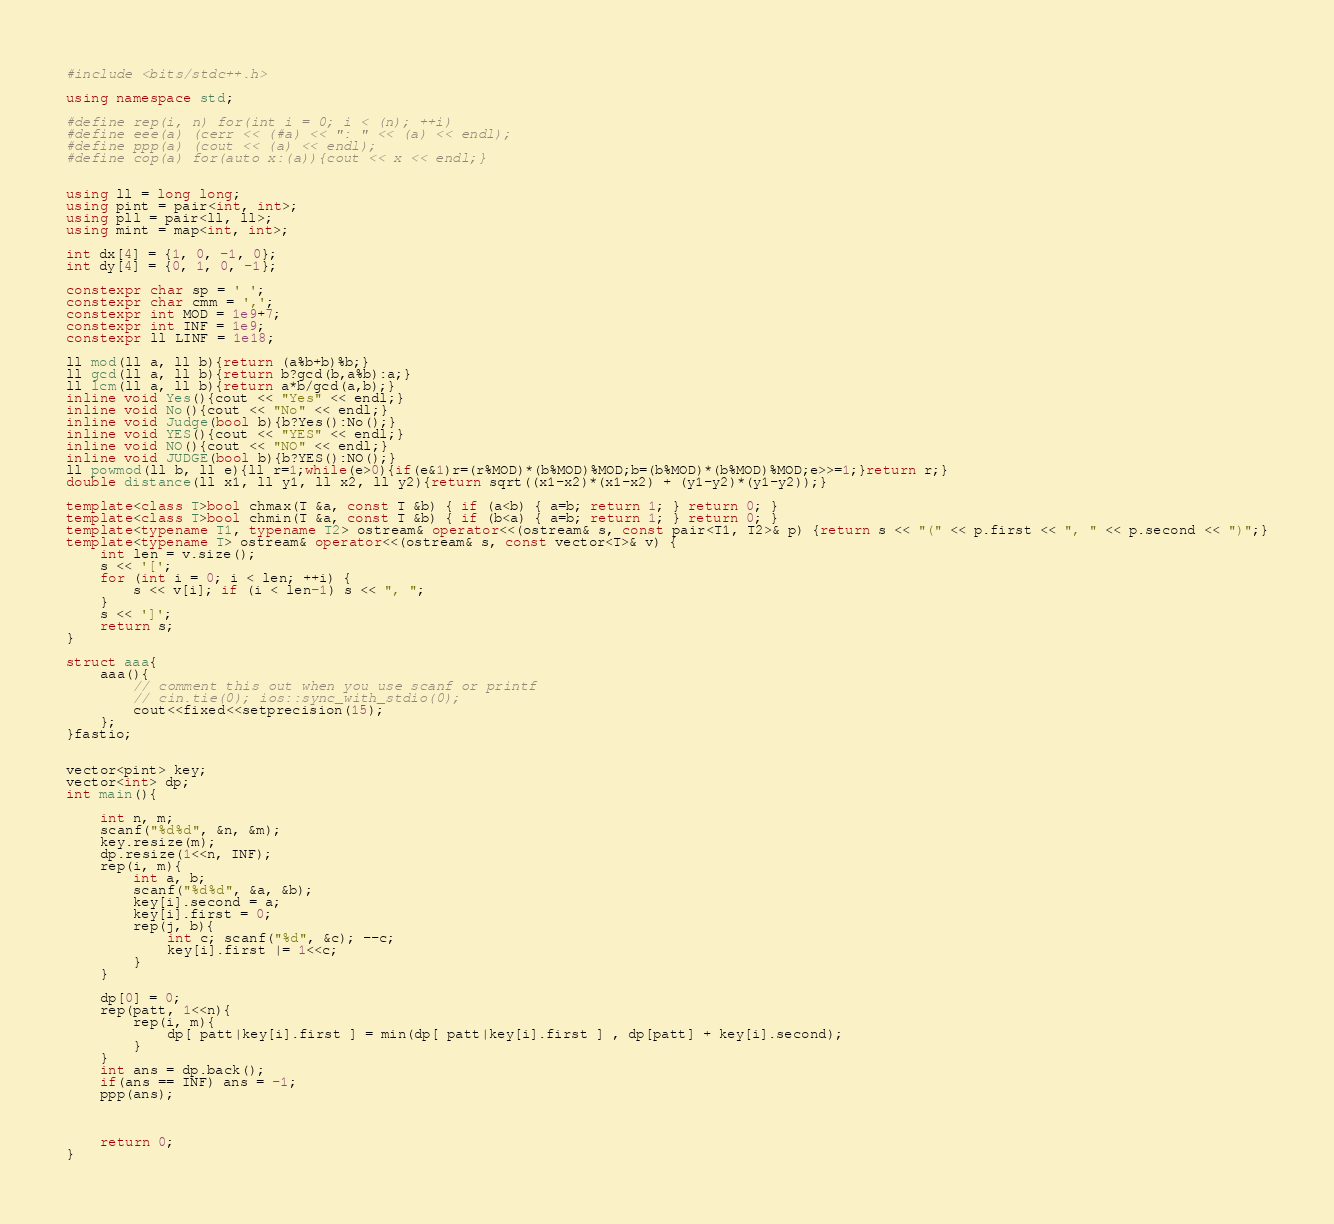Convert code to text. <code><loc_0><loc_0><loc_500><loc_500><_C++_>#include <bits/stdc++.h>

using namespace std;

#define rep(i, n) for(int i = 0; i < (n); ++i)
#define eee(a) (cerr << (#a) << ": " << (a) << endl);
#define ppp(a) (cout << (a) << endl); 
#define cop(a) for(auto x:(a)){cout << x << endl;}


using ll = long long;
using pint = pair<int, int>;
using pll = pair<ll, ll>;
using mint = map<int, int>;

int dx[4] = {1, 0, -1, 0};
int dy[4] = {0, 1, 0, -1};

constexpr char sp = ' ';
constexpr char cmm = ',';
constexpr int MOD = 1e9+7;
constexpr int INF = 1e9;
constexpr ll LINF = 1e18;

ll mod(ll a, ll b){return (a%b+b)%b;}
ll gcd(ll a, ll b){return b?gcd(b,a%b):a;}
ll lcm(ll a, ll b){return a*b/gcd(a,b);}
inline void Yes(){cout << "Yes" << endl;}
inline void No(){cout << "No" << endl;}
inline void Judge(bool b){b?Yes():No();}
inline void YES(){cout << "YES" << endl;}
inline void NO(){cout << "NO" << endl;}
inline void JUDGE(bool b){b?YES():NO();}
ll powmod(ll b, ll e){ll r=1;while(e>0){if(e&1)r=(r%MOD)*(b%MOD)%MOD;b=(b%MOD)*(b%MOD)%MOD;e>>=1;}return r;}
double distance(ll x1, ll y1, ll x2, ll y2){return sqrt((x1-x2)*(x1-x2) + (y1-y2)*(y1-y2));}

template<class T>bool chmax(T &a, const T &b) { if (a<b) { a=b; return 1; } return 0; }
template<class T>bool chmin(T &a, const T &b) { if (b<a) { a=b; return 1; } return 0; }
template<typename T1, typename T2> ostream& operator<<(ostream& s, const pair<T1, T2>& p) {return s << "(" << p.first << ", " << p.second << ")";}
template<typename T> ostream& operator<<(ostream& s, const vector<T>& v) {
    int len = v.size();
    s << '[';
    for (int i = 0; i < len; ++i) {
        s << v[i]; if (i < len-1) s << ", ";
    }
    s << ']';
    return s;
}

struct aaa{
    aaa(){
        // comment this out when you use scanf or printf
        // cin.tie(0); ios::sync_with_stdio(0);
        cout<<fixed<<setprecision(15);
    };
}fastio;


vector<pint> key;
vector<int> dp;
int main(){
    
    int n, m;
    scanf("%d%d", &n, &m);
    key.resize(m);
    dp.resize(1<<n, INF);
    rep(i, m){
        int a, b;
        scanf("%d%d", &a, &b);  
        key[i].second = a;
        key[i].first = 0;
        rep(j, b){
            int c; scanf("%d", &c); --c;
            key[i].first |= 1<<c;
        }
    } 

    dp[0] = 0;
    rep(patt, 1<<n){
        rep(i, m){
            dp[ patt|key[i].first ] = min(dp[ patt|key[i].first ] , dp[patt] + key[i].second); 
        }
    }
    int ans = dp.back();
    if(ans == INF) ans = -1;
    ppp(ans);
    
    
    
    return 0;
}
</code> 